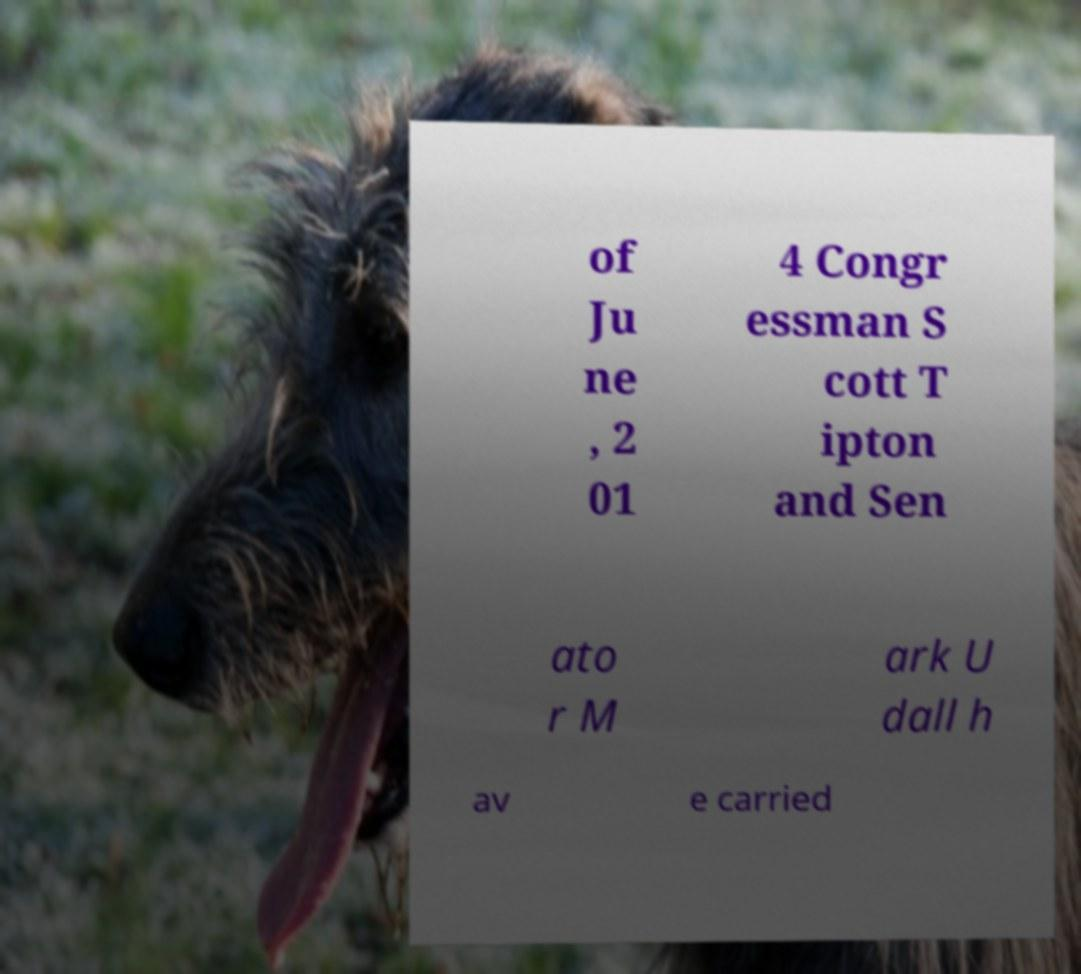Could you assist in decoding the text presented in this image and type it out clearly? of Ju ne , 2 01 4 Congr essman S cott T ipton and Sen ato r M ark U dall h av e carried 